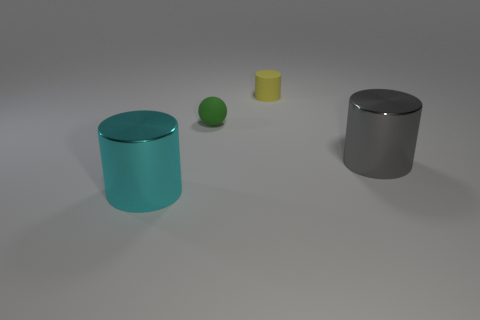How many things are either small gray rubber cubes or rubber objects behind the tiny green sphere?
Offer a very short reply. 1. How many cyan metallic cylinders are there?
Your response must be concise. 1. Is there a cyan cylinder of the same size as the cyan object?
Make the answer very short. No. Are there fewer tiny rubber spheres that are on the right side of the green thing than metal objects?
Offer a terse response. Yes. Do the gray shiny object and the cyan thing have the same size?
Provide a succinct answer. Yes. There is a green thing that is the same material as the yellow cylinder; what size is it?
Offer a terse response. Small. What number of large objects are the same color as the small sphere?
Your response must be concise. 0. Are there fewer shiny cylinders that are left of the big cyan thing than tiny yellow matte cylinders on the left side of the matte cylinder?
Provide a short and direct response. No. Is the shape of the object behind the small green sphere the same as  the large cyan shiny thing?
Offer a very short reply. Yes. Is there any other thing that is the same material as the small sphere?
Your answer should be compact. Yes. 